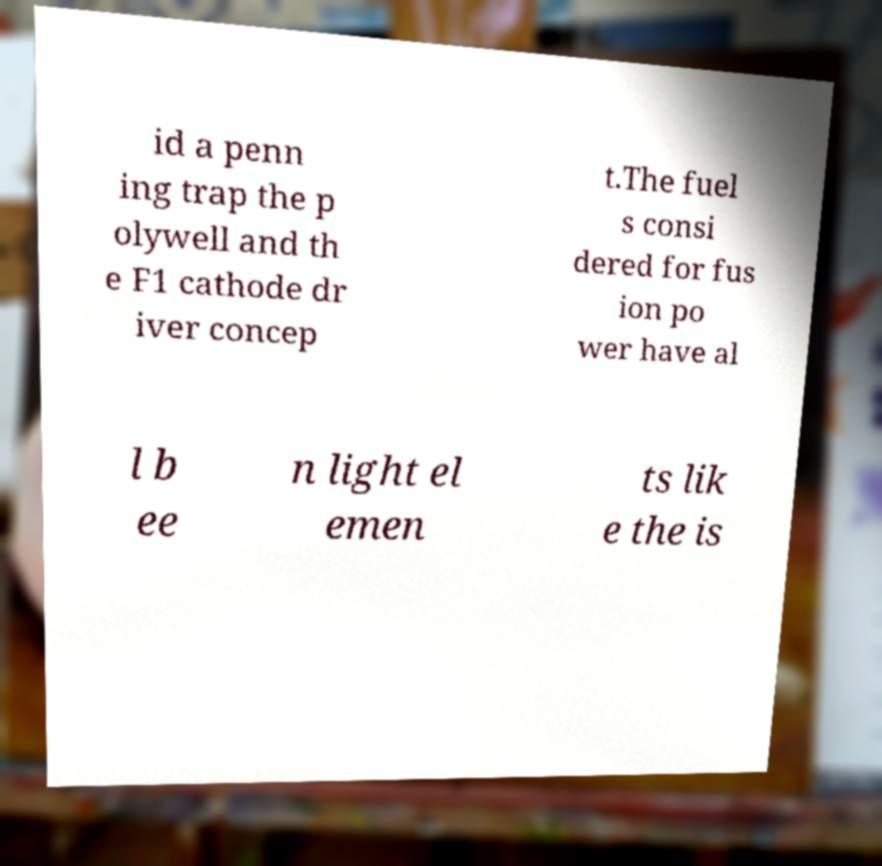Can you accurately transcribe the text from the provided image for me? id a penn ing trap the p olywell and th e F1 cathode dr iver concep t.The fuel s consi dered for fus ion po wer have al l b ee n light el emen ts lik e the is 